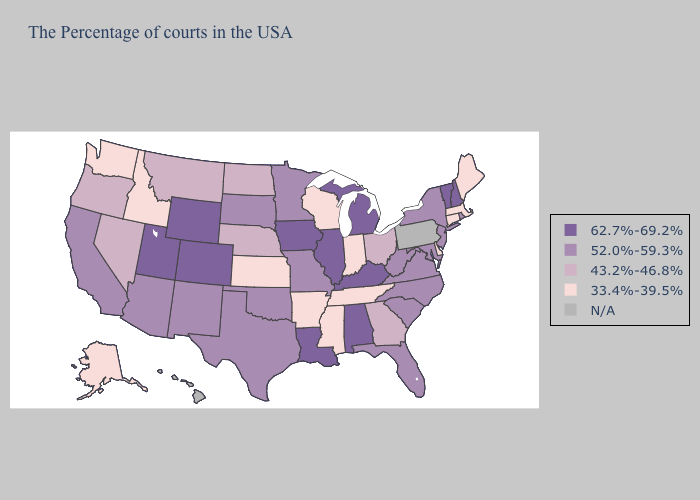Name the states that have a value in the range 52.0%-59.3%?
Quick response, please. Rhode Island, New York, New Jersey, Maryland, Virginia, North Carolina, South Carolina, West Virginia, Florida, Missouri, Minnesota, Oklahoma, Texas, South Dakota, New Mexico, Arizona, California. What is the lowest value in the Northeast?
Write a very short answer. 33.4%-39.5%. What is the value of Delaware?
Concise answer only. 33.4%-39.5%. Name the states that have a value in the range N/A?
Keep it brief. Pennsylvania, Hawaii. Does Kentucky have the lowest value in the USA?
Answer briefly. No. Among the states that border Delaware , which have the highest value?
Give a very brief answer. New Jersey, Maryland. Among the states that border California , which have the lowest value?
Quick response, please. Nevada, Oregon. Name the states that have a value in the range 33.4%-39.5%?
Write a very short answer. Maine, Massachusetts, Connecticut, Delaware, Indiana, Tennessee, Wisconsin, Mississippi, Arkansas, Kansas, Idaho, Washington, Alaska. Which states have the lowest value in the Northeast?
Be succinct. Maine, Massachusetts, Connecticut. Among the states that border North Carolina , does Georgia have the highest value?
Keep it brief. No. Among the states that border Louisiana , which have the highest value?
Keep it brief. Texas. Which states hav the highest value in the MidWest?
Keep it brief. Michigan, Illinois, Iowa. Does Massachusetts have the lowest value in the USA?
Concise answer only. Yes. Among the states that border Connecticut , does Massachusetts have the lowest value?
Give a very brief answer. Yes. 